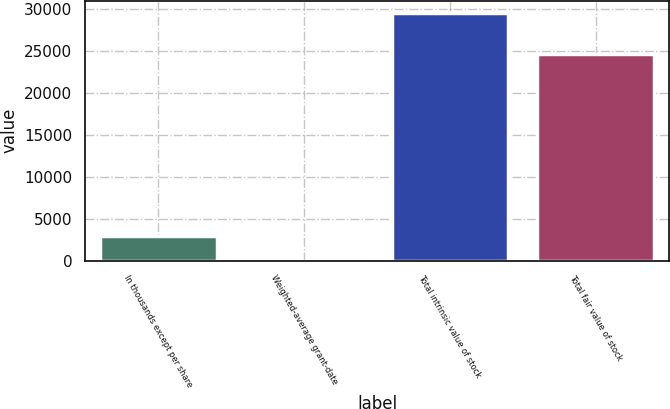Convert chart to OTSL. <chart><loc_0><loc_0><loc_500><loc_500><bar_chart><fcel>In thousands except per share<fcel>Weighted-average grant-date<fcel>Total intrinsic value of stock<fcel>Total fair value of stock<nl><fcel>2961.29<fcel>11.65<fcel>29508<fcel>24614<nl></chart> 